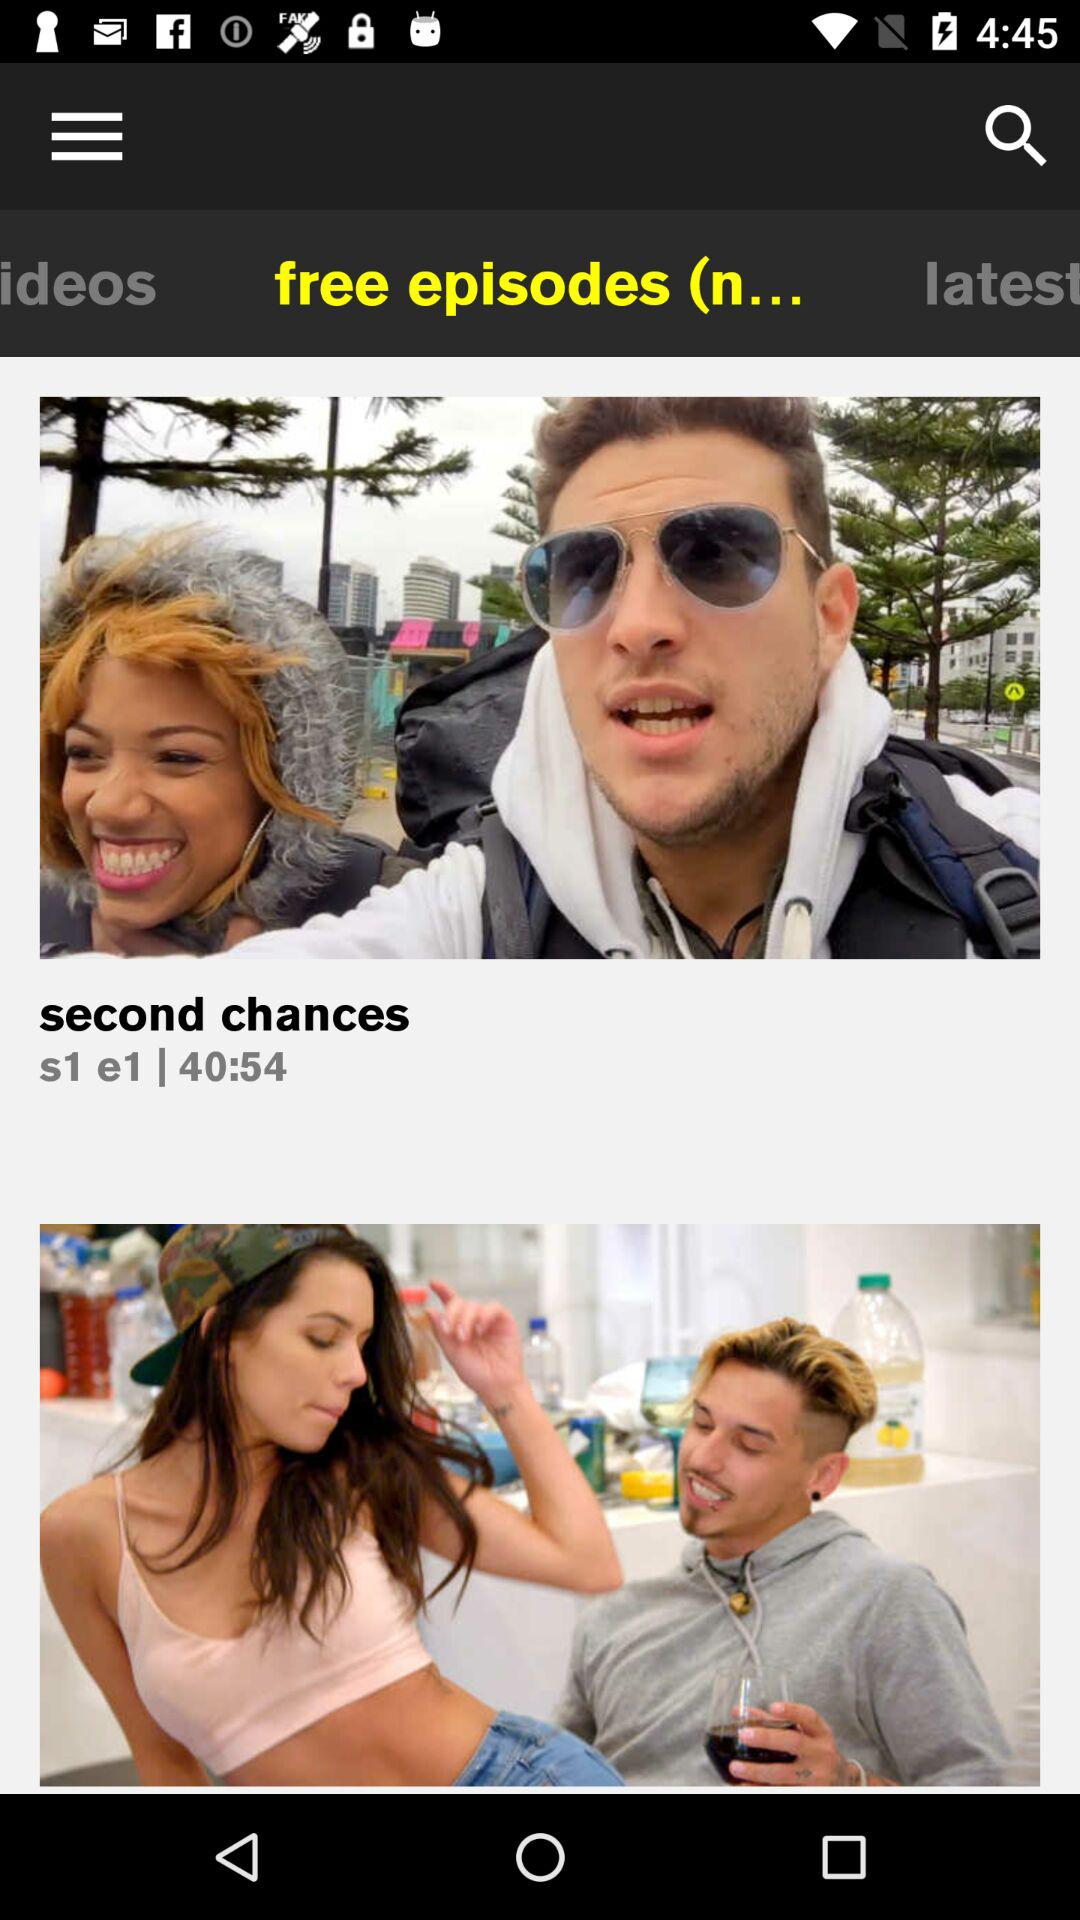Which episode number is currently shown on the screen? The episode that is currently shown on the screen is 1. 